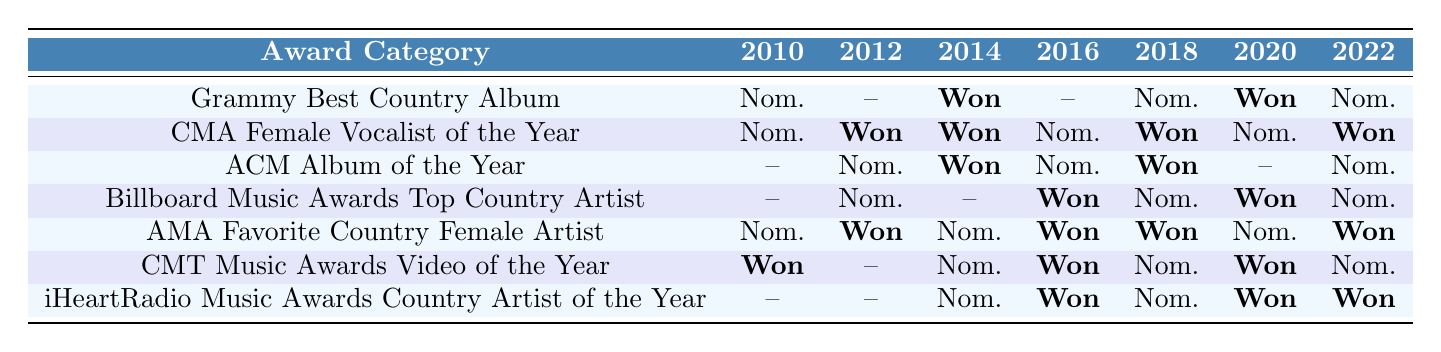What award category did Margo win in 2014? In 2014, Margo won the Grammy for Best Country Album and also the ACM Album of the Year.
Answer: Grammy for Best Country Album and ACM Album of the Year How many times was Margo nominated for the iHeartRadio Music Awards Country Artist of the Year? Margo was nominated for the iHeartRadio Music Awards Country Artist of the Year in 2014, 2018, and 2020, totaling 3 nominations.
Answer: 3 times In which year did Margo win the CMT Music Awards Video of the Year? Margo won the CMT Music Awards Video of the Year in 2010, 2016, and 2020.
Answer: 2010, 2016, and 2020 Was Margo ever nominated for the ACM Album of the Year? Yes, Margo was nominated for the ACM Album of the Year in 2012, 2016, and 2022.
Answer: Yes How many awards did Margo win in 2020? In 2020, Margo won the Grammy for Best Country Album, the Billboard Music Awards for Top Country Artist, the iHeartRadio Music Awards for Country Artist of the Year, and the CMT Music Awards for Video of the Year, making it 4 total wins.
Answer: 4 Which category had the most wins for Margo between 2010 and 2022? The category "CMA Female Vocalist of the Year" had the most wins with a total of 5 wins (years: 2012, 2014, 2018, 2020, 2022).
Answer: CMA Female Vocalist of the Year What is the difference in the number of wins between the CMA Female Vocalist of the Year and the American Music Awards Favorite Country Female Artist? The CMA Female Vocalist of the Year had 5 wins while the American Music Awards Favorite Country Female Artist had 4 wins, resulting in a difference of 1 win.
Answer: 1 win Did Margo receive any nominations for the Billboard Music Awards Top Country Artist in 2012? Yes, Margo was nominated for the Billboard Music Awards Top Country Artist in 2012.
Answer: Yes Which award category did Margo only receive nominations in 2010 and 2018? Margo received nominations for the Grammy Best Country Album only in 2010 and 2018.
Answer: Grammy Best Country Album In how many years did Margo win the CMA Female Vocalist of the Year? Margo won the CMA Female Vocalist of the Year in 2012, 2014, 2018, and 2022, totaling 4 wins.
Answer: 4 years What was the most recent award Margo was nominated for in the year 2022? In 2022, Margo was nominated for the Grammy Best Country Album and the iHeartRadio Music Awards Country Artist of the Year.
Answer: Grammy Best Country Album and iHeartRadio Music Awards Country Artist of the Year 